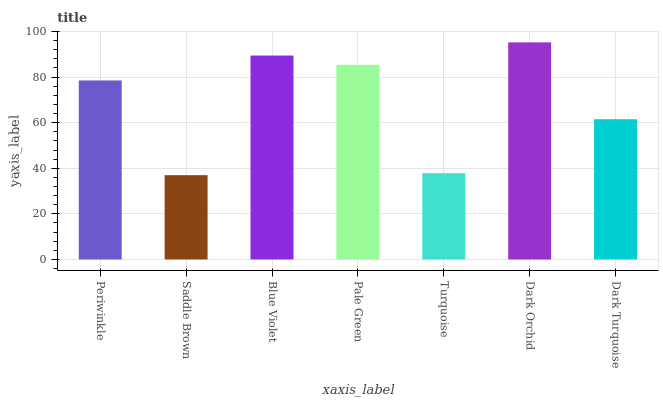Is Saddle Brown the minimum?
Answer yes or no. Yes. Is Dark Orchid the maximum?
Answer yes or no. Yes. Is Blue Violet the minimum?
Answer yes or no. No. Is Blue Violet the maximum?
Answer yes or no. No. Is Blue Violet greater than Saddle Brown?
Answer yes or no. Yes. Is Saddle Brown less than Blue Violet?
Answer yes or no. Yes. Is Saddle Brown greater than Blue Violet?
Answer yes or no. No. Is Blue Violet less than Saddle Brown?
Answer yes or no. No. Is Periwinkle the high median?
Answer yes or no. Yes. Is Periwinkle the low median?
Answer yes or no. Yes. Is Pale Green the high median?
Answer yes or no. No. Is Saddle Brown the low median?
Answer yes or no. No. 